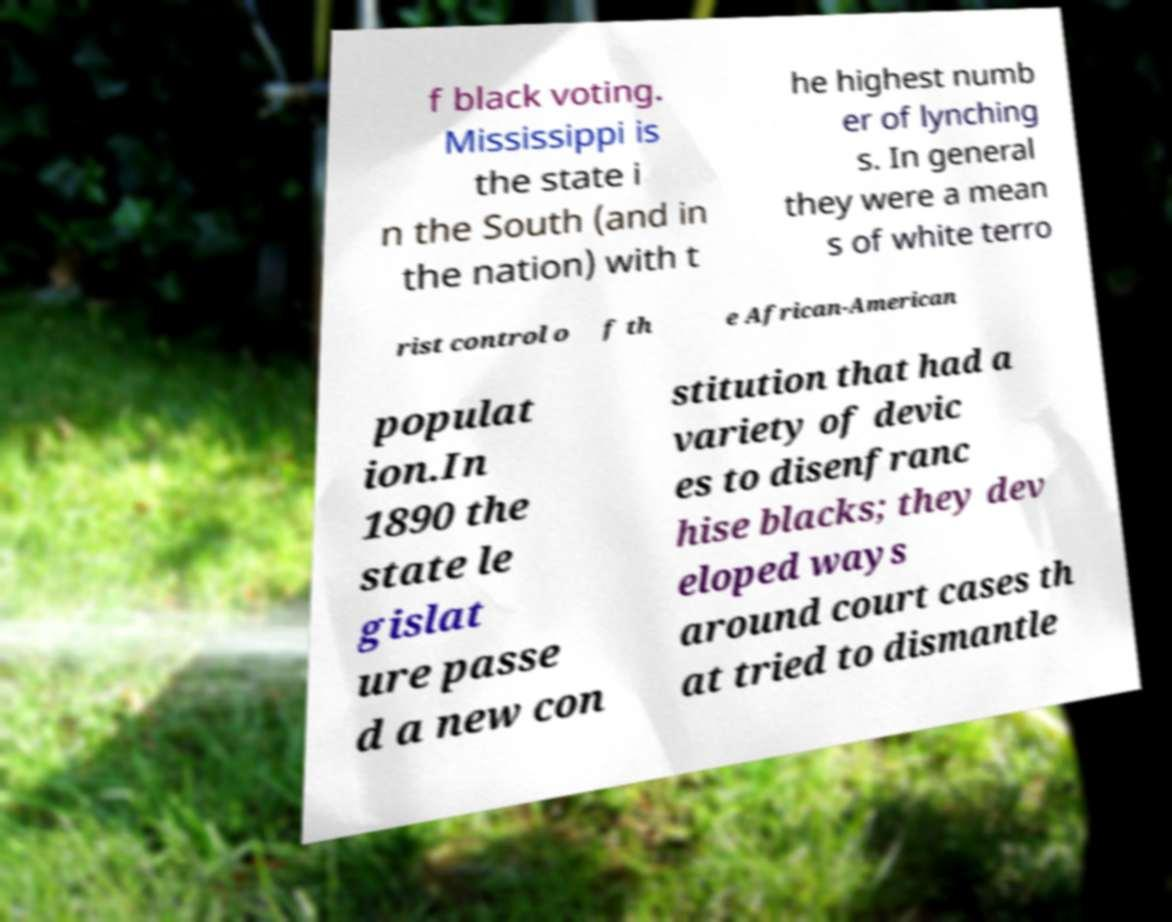Please read and relay the text visible in this image. What does it say? f black voting. Mississippi is the state i n the South (and in the nation) with t he highest numb er of lynching s. In general they were a mean s of white terro rist control o f th e African-American populat ion.In 1890 the state le gislat ure passe d a new con stitution that had a variety of devic es to disenfranc hise blacks; they dev eloped ways around court cases th at tried to dismantle 